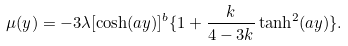<formula> <loc_0><loc_0><loc_500><loc_500>\mu ( y ) = - 3 \lambda [ \cosh ( a y ) ] ^ { b } \{ 1 + \frac { k } { 4 - 3 k } \tanh ^ { 2 } ( a y ) \} .</formula> 